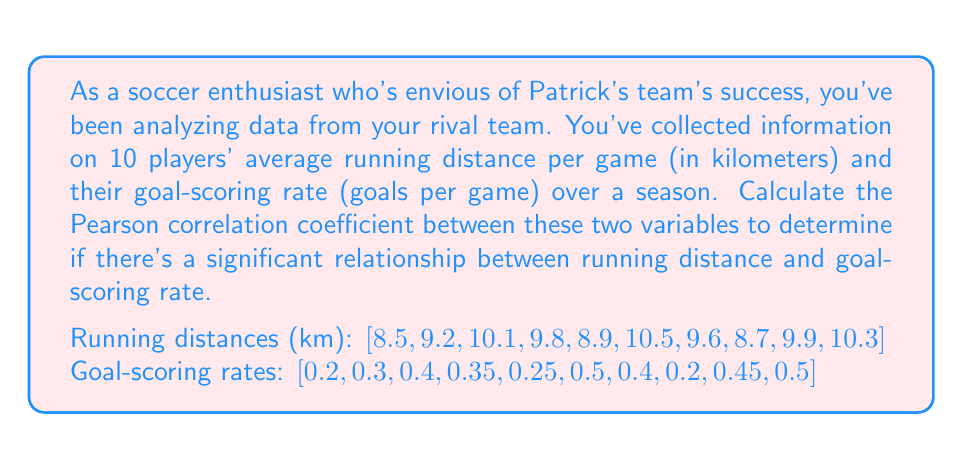What is the answer to this math problem? To calculate the Pearson correlation coefficient (r) between running distance and goal-scoring rate, we'll use the formula:

$$ r = \frac{\sum_{i=1}^{n} (x_i - \bar{x})(y_i - \bar{y})}{\sqrt{\sum_{i=1}^{n} (x_i - \bar{x})^2 \sum_{i=1}^{n} (y_i - \bar{y})^2}} $$

Where:
$x_i$ = running distance for player i
$y_i$ = goal-scoring rate for player i
$\bar{x}$ = mean running distance
$\bar{y}$ = mean goal-scoring rate
$n$ = number of players (10)

Step 1: Calculate means
$\bar{x} = \frac{8.5 + 9.2 + 10.1 + 9.8 + 8.9 + 10.5 + 9.6 + 8.7 + 9.9 + 10.3}{10} = 9.55$ km
$\bar{y} = \frac{0.2 + 0.3 + 0.4 + 0.35 + 0.25 + 0.5 + 0.4 + 0.2 + 0.45 + 0.5}{10} = 0.355$ goals/game

Step 2: Calculate $(x_i - \bar{x})$, $(y_i - \bar{y})$, $(x_i - \bar{x})^2$, $(y_i - \bar{y})^2$, and $(x_i - \bar{x})(y_i - \bar{y})$ for each player.

Step 3: Sum the calculated values:
$\sum (x_i - \bar{x})(y_i - \bar{y}) = 0.9175$
$\sum (x_i - \bar{x})^2 = 4.0075$
$\sum (y_i - \bar{y})^2 = 0.12275$

Step 4: Apply the formula:

$$ r = \frac{0.9175}{\sqrt{4.0075 \times 0.12275}} = \frac{0.9175}{\sqrt{0.4919}} = \frac{0.9175}{0.7014} $$
Answer: $r \approx 0.8235$

This indicates a strong positive correlation between a player's running distance and their goal-scoring rate. 